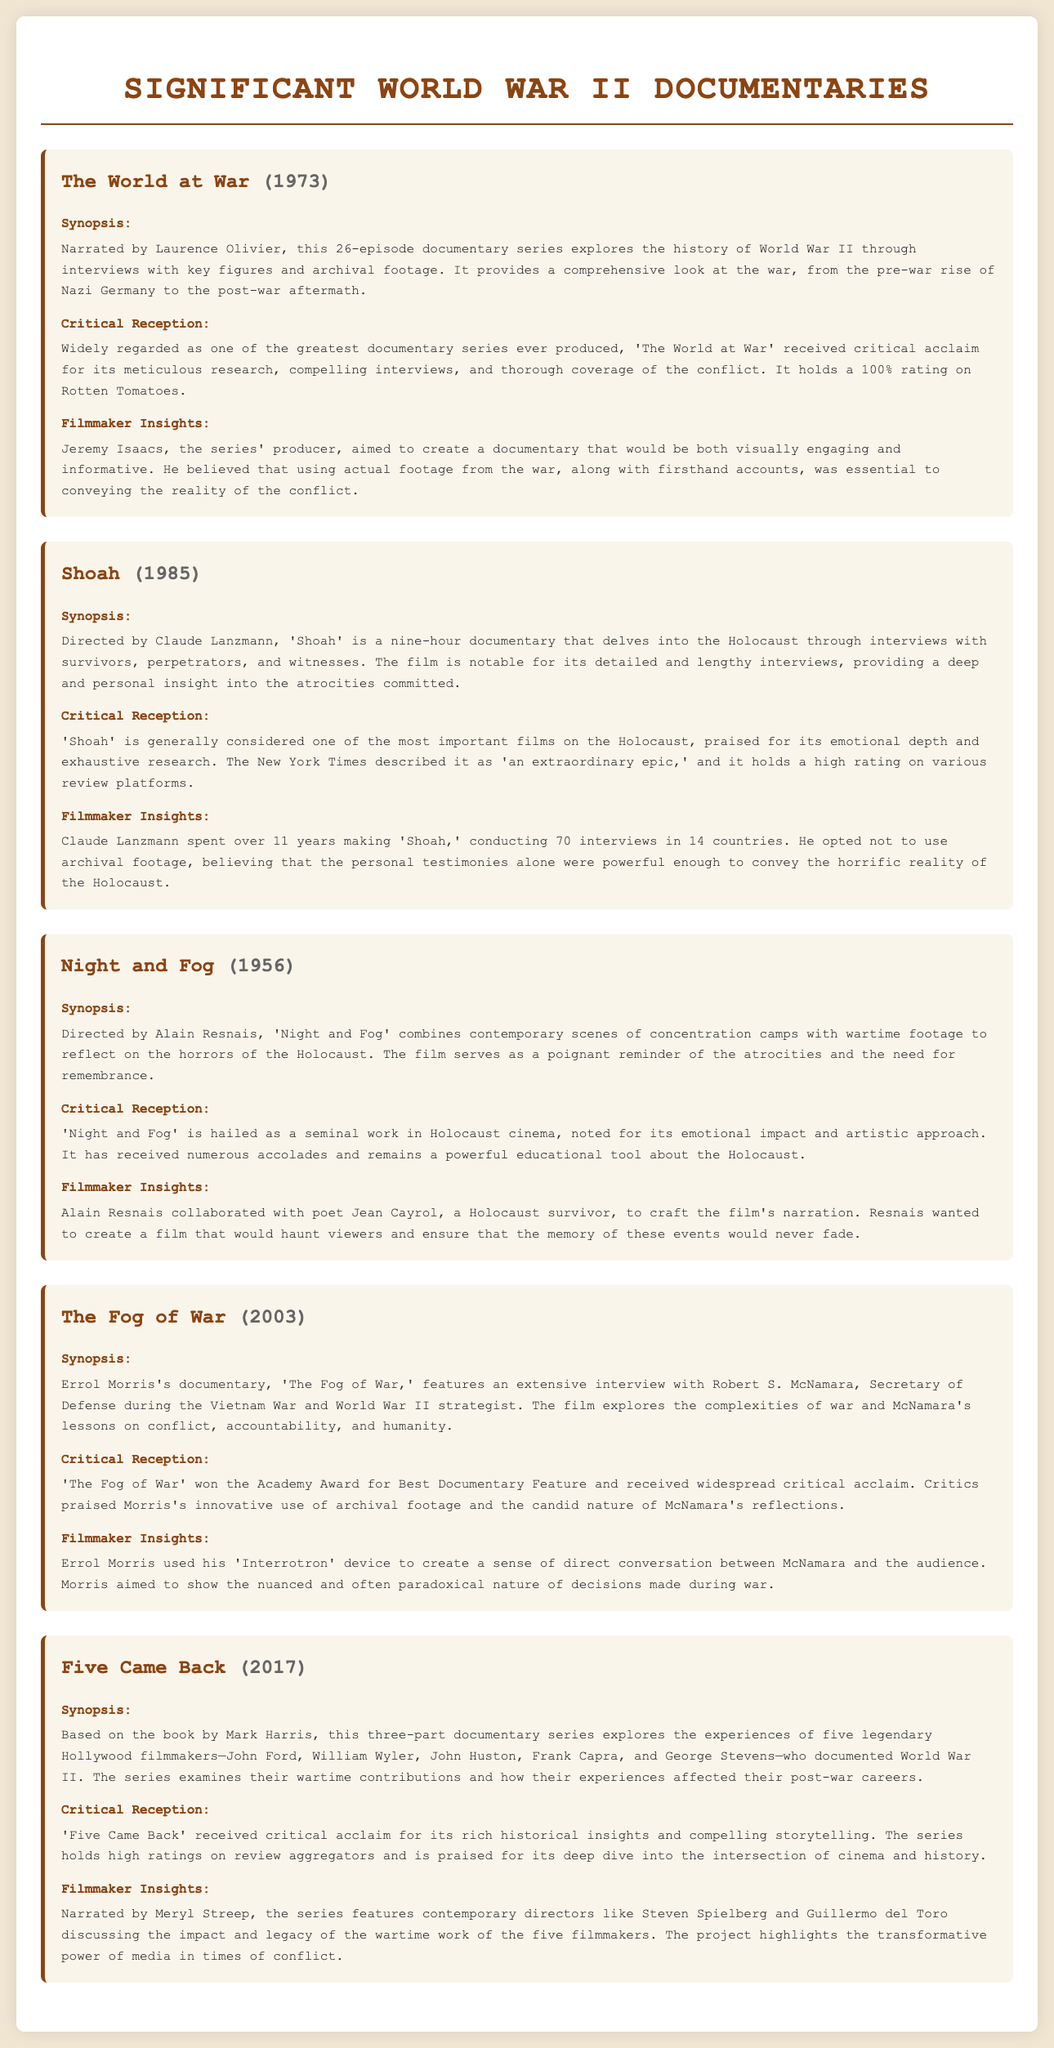What is the title of the 1973 documentary? The title is clearly mentioned in the document.
Answer: The World at War Who directed 'Shoah'? The document specifies the director for each listed documentary.
Answer: Claude Lanzmann What year was 'Night and Fog' released? The release year is associated with the title in each section.
Answer: 1956 Which documentary won the Academy Award for Best Documentary Feature? 'The Fog of War' is highlighted for its accolades in the critical reception section.
Answer: The Fog of War How many episodes are in 'The World at War'? The documentary overview in the document states the number of episodes in the series.
Answer: 26 What is the lasting impact of 'Five Came Back'? The filmmaker insights reflect on the significance of the series relating to film and history.
Answer: Transformative power of media Which documentary features interviews exclusively without archival footage? The document notes the unique approach taken by the filmmaker in this documentary.
Answer: Shoah What type of insights are provided by Meryl Streep in 'Five Came Back'? The section mentions the involvement of contemporary directors discussing various aspects.
Answer: Impact and legacy What device did Errol Morris use in 'The Fog of War'? The filmmaker insights specify the tool employed during interviews.
Answer: Interrotron 